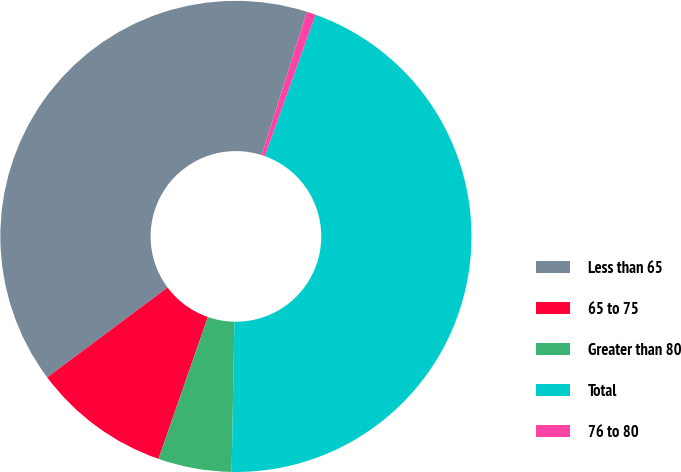Convert chart. <chart><loc_0><loc_0><loc_500><loc_500><pie_chart><fcel>Less than 65<fcel>65 to 75<fcel>Greater than 80<fcel>Total<fcel>76 to 80<nl><fcel>40.08%<fcel>9.46%<fcel>5.04%<fcel>44.8%<fcel>0.62%<nl></chart> 